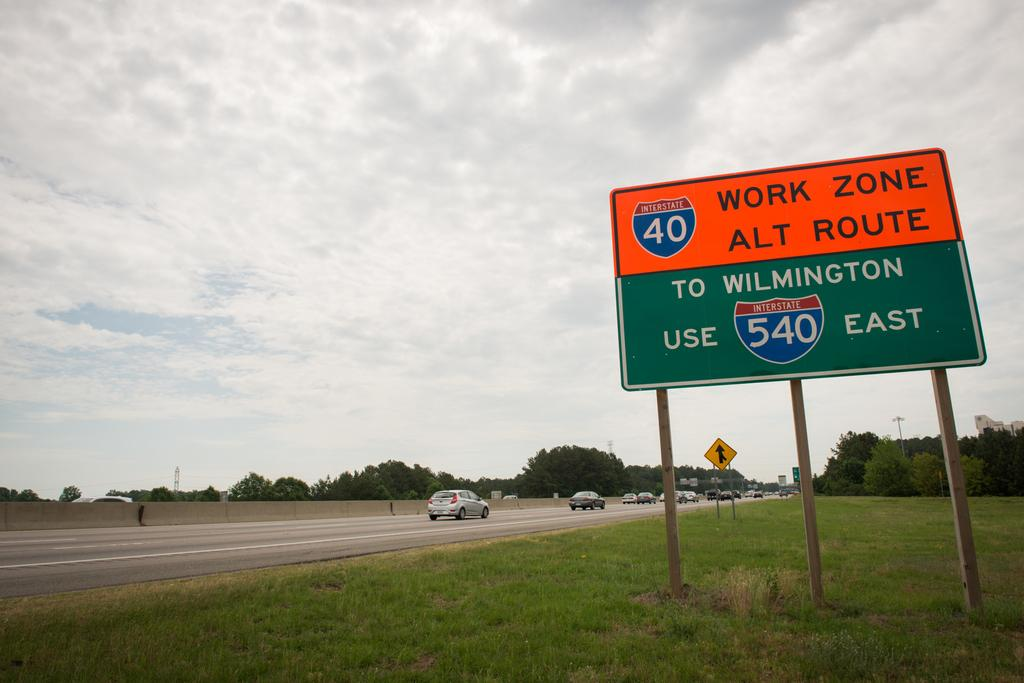<image>
Summarize the visual content of the image. A sign by a highway reading Work Zone Alt Route. 